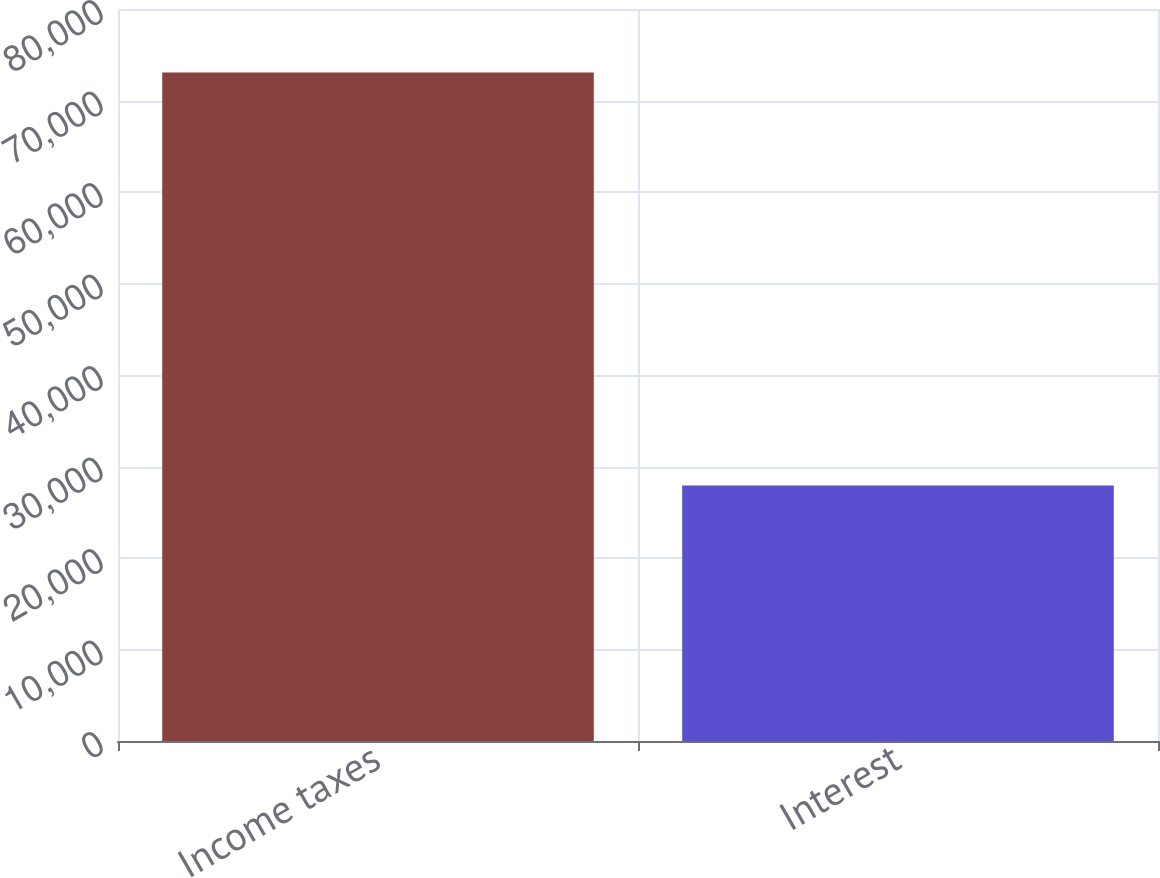<chart> <loc_0><loc_0><loc_500><loc_500><bar_chart><fcel>Income taxes<fcel>Interest<nl><fcel>73067<fcel>27931<nl></chart> 